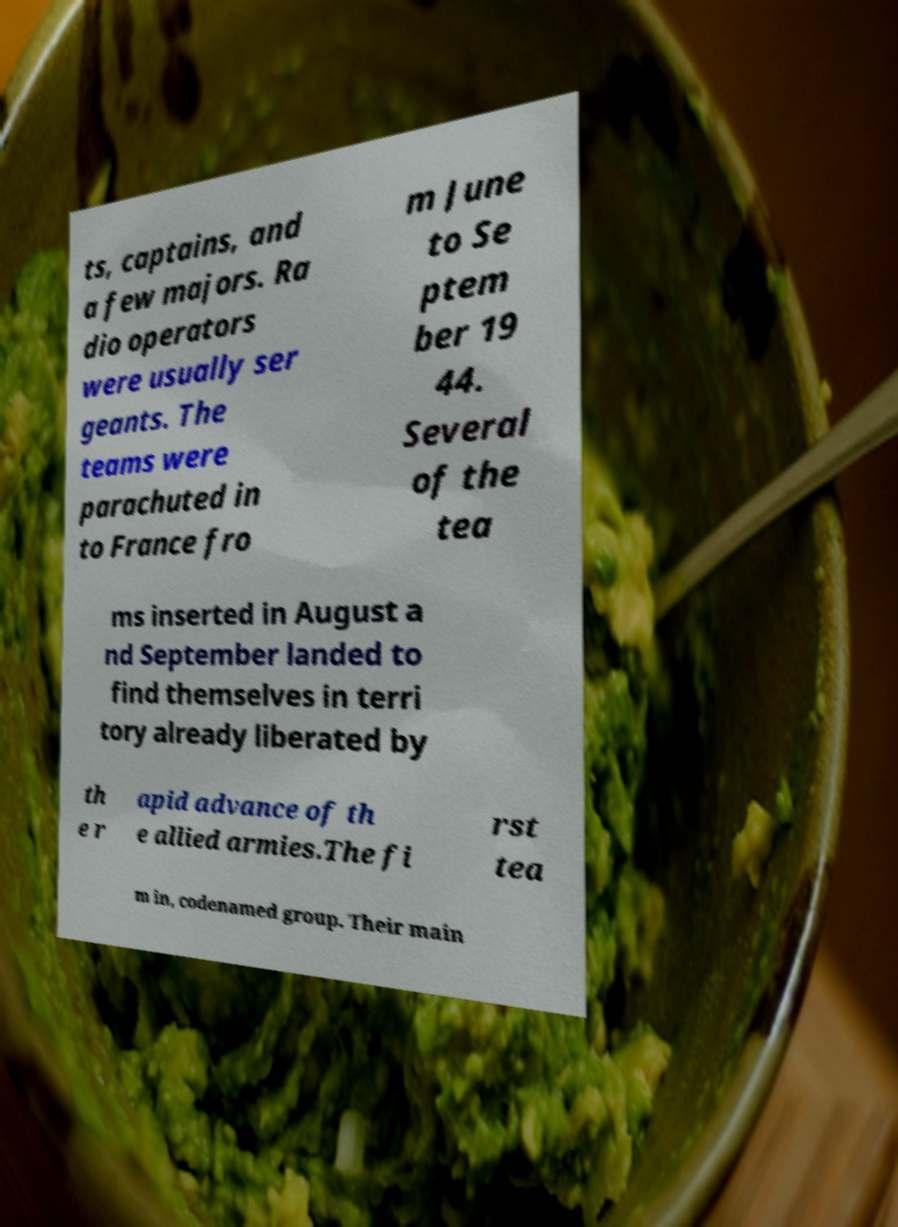For documentation purposes, I need the text within this image transcribed. Could you provide that? ts, captains, and a few majors. Ra dio operators were usually ser geants. The teams were parachuted in to France fro m June to Se ptem ber 19 44. Several of the tea ms inserted in August a nd September landed to find themselves in terri tory already liberated by th e r apid advance of th e allied armies.The fi rst tea m in, codenamed group. Their main 